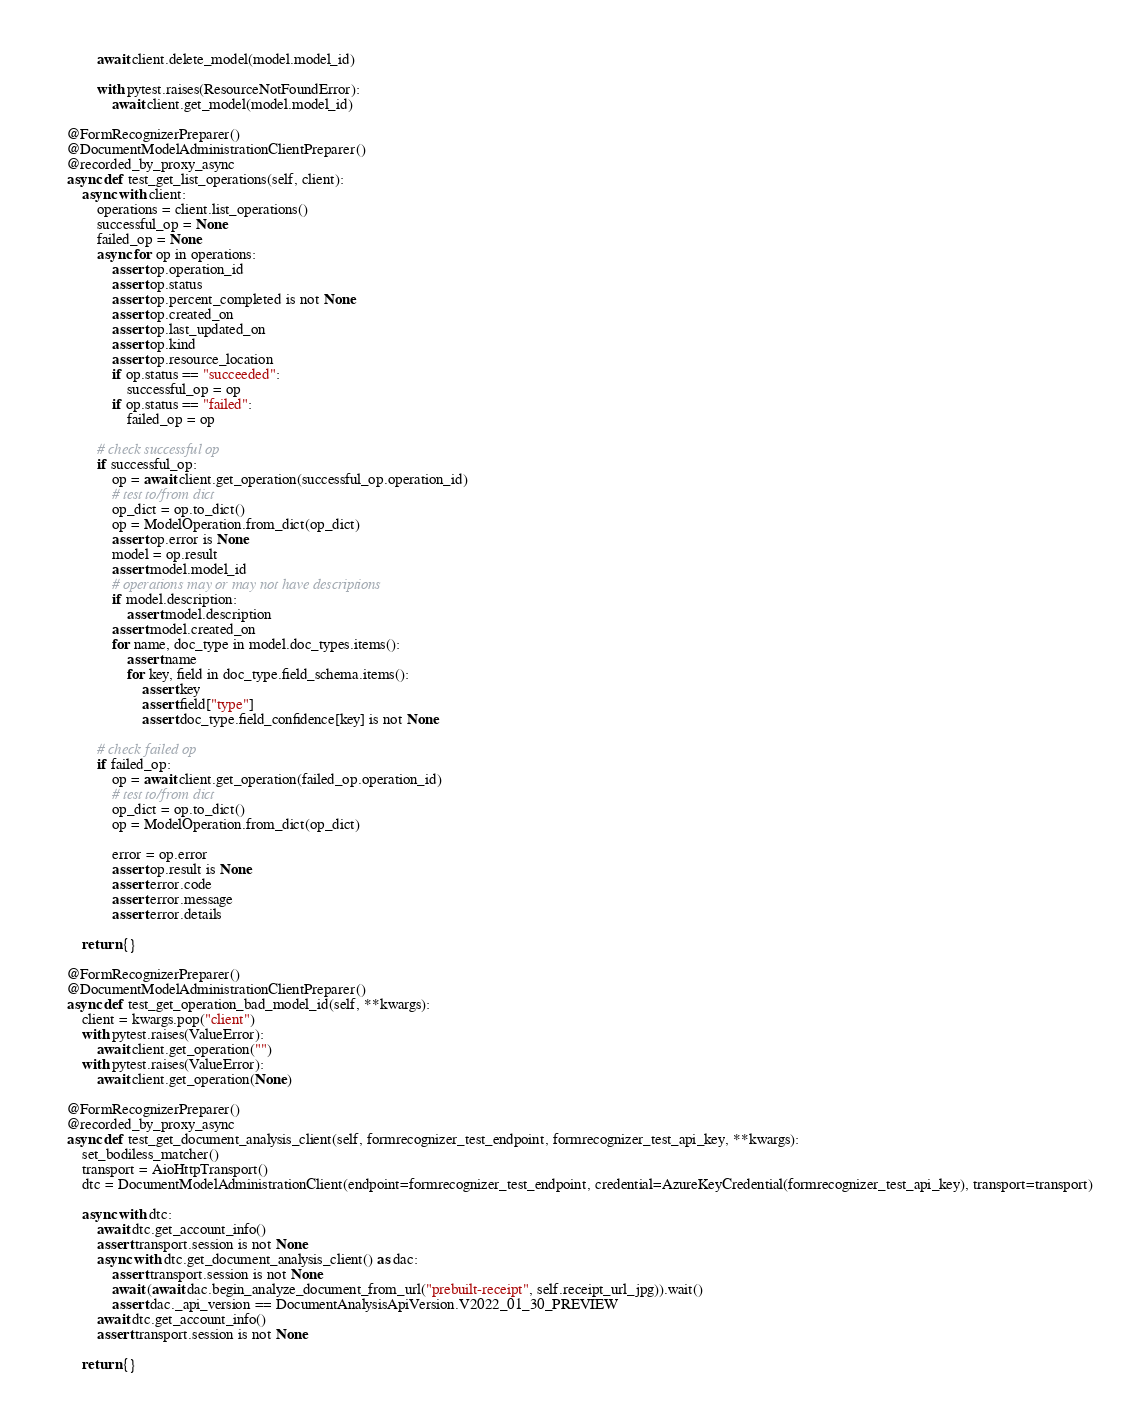Convert code to text. <code><loc_0><loc_0><loc_500><loc_500><_Python_>            await client.delete_model(model.model_id)

            with pytest.raises(ResourceNotFoundError):
                await client.get_model(model.model_id)

    @FormRecognizerPreparer()
    @DocumentModelAdministrationClientPreparer()
    @recorded_by_proxy_async
    async def test_get_list_operations(self, client):
        async with client:
            operations = client.list_operations()
            successful_op = None
            failed_op = None
            async for op in operations:
                assert op.operation_id
                assert op.status
                assert op.percent_completed is not None
                assert op.created_on
                assert op.last_updated_on
                assert op.kind
                assert op.resource_location
                if op.status == "succeeded":
                    successful_op = op
                if op.status == "failed":
                    failed_op = op

            # check successful op
            if successful_op:
                op = await client.get_operation(successful_op.operation_id)
                # test to/from dict
                op_dict = op.to_dict()
                op = ModelOperation.from_dict(op_dict)
                assert op.error is None
                model = op.result
                assert model.model_id
                # operations may or may not have descriptions
                if model.description:
                    assert model.description
                assert model.created_on
                for name, doc_type in model.doc_types.items():
                    assert name
                    for key, field in doc_type.field_schema.items():
                        assert key
                        assert field["type"]
                        assert doc_type.field_confidence[key] is not None

            # check failed op
            if failed_op:
                op = await client.get_operation(failed_op.operation_id)
                # test to/from dict
                op_dict = op.to_dict()
                op = ModelOperation.from_dict(op_dict)

                error = op.error
                assert op.result is None
                assert error.code
                assert error.message
                assert error.details

        return {}

    @FormRecognizerPreparer()
    @DocumentModelAdministrationClientPreparer()
    async def test_get_operation_bad_model_id(self, **kwargs):
        client = kwargs.pop("client")
        with pytest.raises(ValueError):
            await client.get_operation("")
        with pytest.raises(ValueError):
            await client.get_operation(None)

    @FormRecognizerPreparer()
    @recorded_by_proxy_async
    async def test_get_document_analysis_client(self, formrecognizer_test_endpoint, formrecognizer_test_api_key, **kwargs):
        set_bodiless_matcher()  
        transport = AioHttpTransport()
        dtc = DocumentModelAdministrationClient(endpoint=formrecognizer_test_endpoint, credential=AzureKeyCredential(formrecognizer_test_api_key), transport=transport)

        async with dtc:
            await dtc.get_account_info()
            assert transport.session is not None
            async with dtc.get_document_analysis_client() as dac:
                assert transport.session is not None
                await (await dac.begin_analyze_document_from_url("prebuilt-receipt", self.receipt_url_jpg)).wait()
                assert dac._api_version == DocumentAnalysisApiVersion.V2022_01_30_PREVIEW
            await dtc.get_account_info()
            assert transport.session is not None

        return {}
</code> 